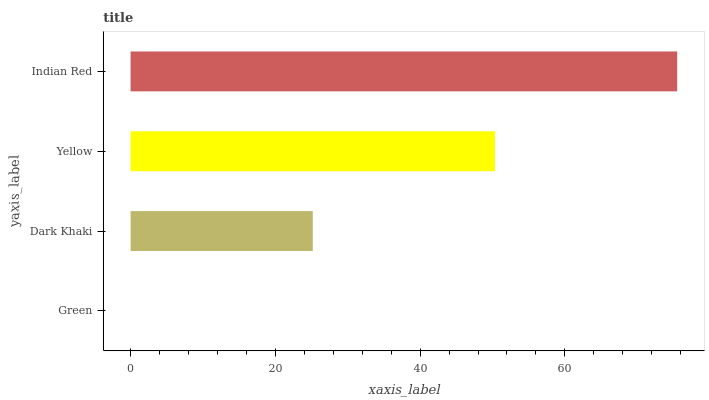Is Green the minimum?
Answer yes or no. Yes. Is Indian Red the maximum?
Answer yes or no. Yes. Is Dark Khaki the minimum?
Answer yes or no. No. Is Dark Khaki the maximum?
Answer yes or no. No. Is Dark Khaki greater than Green?
Answer yes or no. Yes. Is Green less than Dark Khaki?
Answer yes or no. Yes. Is Green greater than Dark Khaki?
Answer yes or no. No. Is Dark Khaki less than Green?
Answer yes or no. No. Is Yellow the high median?
Answer yes or no. Yes. Is Dark Khaki the low median?
Answer yes or no. Yes. Is Dark Khaki the high median?
Answer yes or no. No. Is Indian Red the low median?
Answer yes or no. No. 